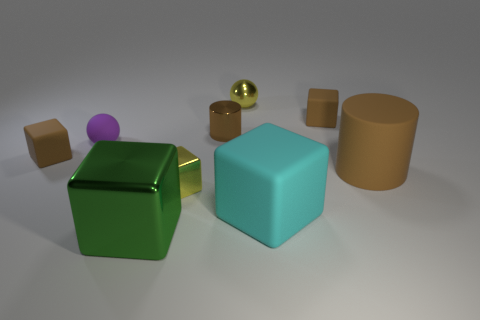Subtract all large matte blocks. How many blocks are left? 4 Subtract all cyan cubes. How many cubes are left? 4 Add 1 tiny yellow blocks. How many objects exist? 10 Subtract all blue cubes. Subtract all blue cylinders. How many cubes are left? 5 Subtract all cubes. How many objects are left? 4 Add 2 tiny balls. How many tiny balls exist? 4 Subtract 1 yellow spheres. How many objects are left? 8 Subtract all big matte blocks. Subtract all shiny blocks. How many objects are left? 6 Add 5 large cylinders. How many large cylinders are left? 6 